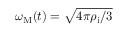<formula> <loc_0><loc_0><loc_500><loc_500>\omega _ { M } ( t ) = \sqrt { 4 \pi \rho _ { i } / 3 }</formula> 